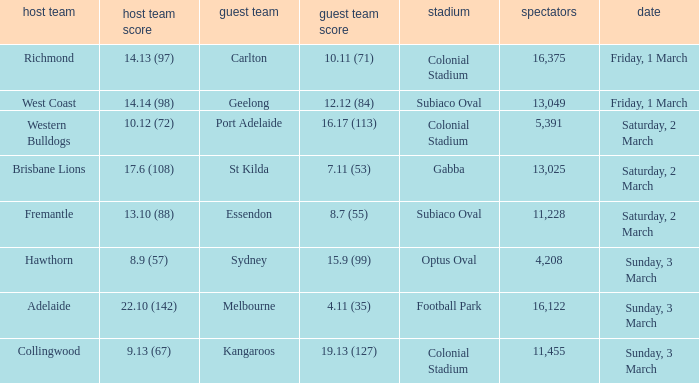Who is the away team when the home team scored 17.6 (108)? St Kilda. 